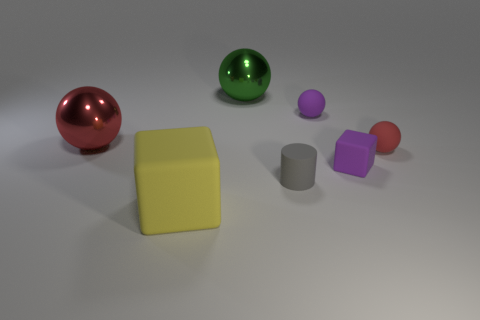The image has a variety of geometric shapes; can you identify them? Certainly, the image showcases spheres, cubes, and a cylinder. Specifically, there are two spheres, a large cube, and two smaller cubes appearing to be of different sizes, as well as a single cylinder. What can you tell me about the lighting in the image? The lighting in the image appears to be soft and diffused, providing uniform illumination without harsh shadows, suggesting a controlled indoor setting, likely to showcase the objects clearly. 